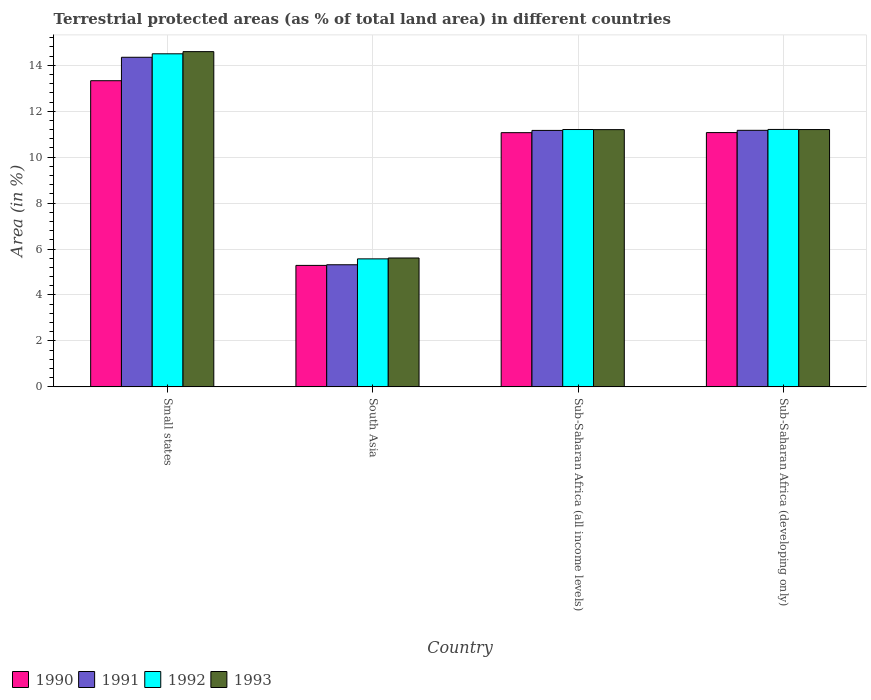Are the number of bars on each tick of the X-axis equal?
Keep it short and to the point. Yes. In how many cases, is the number of bars for a given country not equal to the number of legend labels?
Provide a short and direct response. 0. What is the percentage of terrestrial protected land in 1992 in South Asia?
Ensure brevity in your answer.  5.57. Across all countries, what is the maximum percentage of terrestrial protected land in 1991?
Offer a terse response. 14.35. Across all countries, what is the minimum percentage of terrestrial protected land in 1992?
Your response must be concise. 5.57. In which country was the percentage of terrestrial protected land in 1990 maximum?
Your answer should be very brief. Small states. What is the total percentage of terrestrial protected land in 1992 in the graph?
Your answer should be compact. 42.48. What is the difference between the percentage of terrestrial protected land in 1990 in South Asia and that in Sub-Saharan Africa (developing only)?
Provide a short and direct response. -5.78. What is the difference between the percentage of terrestrial protected land in 1992 in Sub-Saharan Africa (developing only) and the percentage of terrestrial protected land in 1993 in Small states?
Your response must be concise. -3.39. What is the average percentage of terrestrial protected land in 1993 per country?
Offer a very short reply. 10.65. What is the difference between the percentage of terrestrial protected land of/in 1991 and percentage of terrestrial protected land of/in 1990 in Sub-Saharan Africa (developing only)?
Offer a very short reply. 0.1. In how many countries, is the percentage of terrestrial protected land in 1993 greater than 4.8 %?
Make the answer very short. 4. What is the ratio of the percentage of terrestrial protected land in 1992 in Small states to that in Sub-Saharan Africa (all income levels)?
Your response must be concise. 1.29. Is the percentage of terrestrial protected land in 1991 in Small states less than that in Sub-Saharan Africa (developing only)?
Provide a succinct answer. No. What is the difference between the highest and the second highest percentage of terrestrial protected land in 1993?
Provide a succinct answer. -0. What is the difference between the highest and the lowest percentage of terrestrial protected land in 1992?
Make the answer very short. 8.93. In how many countries, is the percentage of terrestrial protected land in 1992 greater than the average percentage of terrestrial protected land in 1992 taken over all countries?
Your answer should be very brief. 3. Is the sum of the percentage of terrestrial protected land in 1991 in South Asia and Sub-Saharan Africa (all income levels) greater than the maximum percentage of terrestrial protected land in 1993 across all countries?
Give a very brief answer. Yes. What does the 4th bar from the right in South Asia represents?
Ensure brevity in your answer.  1990. How many bars are there?
Ensure brevity in your answer.  16. Does the graph contain any zero values?
Give a very brief answer. No. How many legend labels are there?
Give a very brief answer. 4. How are the legend labels stacked?
Make the answer very short. Horizontal. What is the title of the graph?
Your answer should be very brief. Terrestrial protected areas (as % of total land area) in different countries. What is the label or title of the Y-axis?
Provide a short and direct response. Area (in %). What is the Area (in %) of 1990 in Small states?
Offer a terse response. 13.33. What is the Area (in %) in 1991 in Small states?
Provide a succinct answer. 14.35. What is the Area (in %) in 1992 in Small states?
Provide a succinct answer. 14.5. What is the Area (in %) of 1993 in Small states?
Make the answer very short. 14.59. What is the Area (in %) of 1990 in South Asia?
Your answer should be very brief. 5.29. What is the Area (in %) of 1991 in South Asia?
Your answer should be compact. 5.32. What is the Area (in %) of 1992 in South Asia?
Provide a short and direct response. 5.57. What is the Area (in %) in 1993 in South Asia?
Provide a succinct answer. 5.61. What is the Area (in %) in 1990 in Sub-Saharan Africa (all income levels)?
Make the answer very short. 11.07. What is the Area (in %) of 1991 in Sub-Saharan Africa (all income levels)?
Offer a very short reply. 11.16. What is the Area (in %) in 1992 in Sub-Saharan Africa (all income levels)?
Give a very brief answer. 11.2. What is the Area (in %) in 1993 in Sub-Saharan Africa (all income levels)?
Provide a short and direct response. 11.2. What is the Area (in %) of 1990 in Sub-Saharan Africa (developing only)?
Keep it short and to the point. 11.07. What is the Area (in %) in 1991 in Sub-Saharan Africa (developing only)?
Your response must be concise. 11.17. What is the Area (in %) of 1992 in Sub-Saharan Africa (developing only)?
Your answer should be very brief. 11.21. What is the Area (in %) of 1993 in Sub-Saharan Africa (developing only)?
Your response must be concise. 11.2. Across all countries, what is the maximum Area (in %) of 1990?
Offer a very short reply. 13.33. Across all countries, what is the maximum Area (in %) in 1991?
Keep it short and to the point. 14.35. Across all countries, what is the maximum Area (in %) of 1992?
Ensure brevity in your answer.  14.5. Across all countries, what is the maximum Area (in %) in 1993?
Offer a very short reply. 14.59. Across all countries, what is the minimum Area (in %) in 1990?
Your response must be concise. 5.29. Across all countries, what is the minimum Area (in %) of 1991?
Ensure brevity in your answer.  5.32. Across all countries, what is the minimum Area (in %) of 1992?
Offer a very short reply. 5.57. Across all countries, what is the minimum Area (in %) in 1993?
Give a very brief answer. 5.61. What is the total Area (in %) of 1990 in the graph?
Offer a very short reply. 40.75. What is the total Area (in %) of 1991 in the graph?
Your answer should be very brief. 42. What is the total Area (in %) in 1992 in the graph?
Your answer should be very brief. 42.48. What is the total Area (in %) of 1993 in the graph?
Your answer should be very brief. 42.6. What is the difference between the Area (in %) of 1990 in Small states and that in South Asia?
Your answer should be very brief. 8.04. What is the difference between the Area (in %) in 1991 in Small states and that in South Asia?
Offer a terse response. 9.03. What is the difference between the Area (in %) in 1992 in Small states and that in South Asia?
Your answer should be very brief. 8.93. What is the difference between the Area (in %) in 1993 in Small states and that in South Asia?
Offer a very short reply. 8.98. What is the difference between the Area (in %) in 1990 in Small states and that in Sub-Saharan Africa (all income levels)?
Provide a succinct answer. 2.26. What is the difference between the Area (in %) in 1991 in Small states and that in Sub-Saharan Africa (all income levels)?
Your answer should be very brief. 3.18. What is the difference between the Area (in %) of 1992 in Small states and that in Sub-Saharan Africa (all income levels)?
Offer a terse response. 3.3. What is the difference between the Area (in %) of 1993 in Small states and that in Sub-Saharan Africa (all income levels)?
Offer a terse response. 3.4. What is the difference between the Area (in %) of 1990 in Small states and that in Sub-Saharan Africa (developing only)?
Make the answer very short. 2.26. What is the difference between the Area (in %) of 1991 in Small states and that in Sub-Saharan Africa (developing only)?
Your answer should be very brief. 3.18. What is the difference between the Area (in %) of 1992 in Small states and that in Sub-Saharan Africa (developing only)?
Your answer should be very brief. 3.29. What is the difference between the Area (in %) of 1993 in Small states and that in Sub-Saharan Africa (developing only)?
Provide a succinct answer. 3.39. What is the difference between the Area (in %) of 1990 in South Asia and that in Sub-Saharan Africa (all income levels)?
Your answer should be very brief. -5.78. What is the difference between the Area (in %) of 1991 in South Asia and that in Sub-Saharan Africa (all income levels)?
Your answer should be very brief. -5.85. What is the difference between the Area (in %) of 1992 in South Asia and that in Sub-Saharan Africa (all income levels)?
Provide a short and direct response. -5.63. What is the difference between the Area (in %) of 1993 in South Asia and that in Sub-Saharan Africa (all income levels)?
Offer a very short reply. -5.59. What is the difference between the Area (in %) of 1990 in South Asia and that in Sub-Saharan Africa (developing only)?
Keep it short and to the point. -5.78. What is the difference between the Area (in %) in 1991 in South Asia and that in Sub-Saharan Africa (developing only)?
Offer a very short reply. -5.85. What is the difference between the Area (in %) of 1992 in South Asia and that in Sub-Saharan Africa (developing only)?
Provide a succinct answer. -5.63. What is the difference between the Area (in %) in 1993 in South Asia and that in Sub-Saharan Africa (developing only)?
Offer a terse response. -5.59. What is the difference between the Area (in %) in 1990 in Sub-Saharan Africa (all income levels) and that in Sub-Saharan Africa (developing only)?
Your response must be concise. -0. What is the difference between the Area (in %) of 1991 in Sub-Saharan Africa (all income levels) and that in Sub-Saharan Africa (developing only)?
Your answer should be very brief. -0. What is the difference between the Area (in %) in 1992 in Sub-Saharan Africa (all income levels) and that in Sub-Saharan Africa (developing only)?
Ensure brevity in your answer.  -0. What is the difference between the Area (in %) of 1993 in Sub-Saharan Africa (all income levels) and that in Sub-Saharan Africa (developing only)?
Your answer should be very brief. -0. What is the difference between the Area (in %) in 1990 in Small states and the Area (in %) in 1991 in South Asia?
Provide a succinct answer. 8.01. What is the difference between the Area (in %) of 1990 in Small states and the Area (in %) of 1992 in South Asia?
Provide a succinct answer. 7.76. What is the difference between the Area (in %) in 1990 in Small states and the Area (in %) in 1993 in South Asia?
Give a very brief answer. 7.72. What is the difference between the Area (in %) of 1991 in Small states and the Area (in %) of 1992 in South Asia?
Provide a succinct answer. 8.78. What is the difference between the Area (in %) of 1991 in Small states and the Area (in %) of 1993 in South Asia?
Make the answer very short. 8.74. What is the difference between the Area (in %) of 1992 in Small states and the Area (in %) of 1993 in South Asia?
Your answer should be compact. 8.89. What is the difference between the Area (in %) of 1990 in Small states and the Area (in %) of 1991 in Sub-Saharan Africa (all income levels)?
Ensure brevity in your answer.  2.16. What is the difference between the Area (in %) of 1990 in Small states and the Area (in %) of 1992 in Sub-Saharan Africa (all income levels)?
Provide a short and direct response. 2.13. What is the difference between the Area (in %) in 1990 in Small states and the Area (in %) in 1993 in Sub-Saharan Africa (all income levels)?
Keep it short and to the point. 2.13. What is the difference between the Area (in %) in 1991 in Small states and the Area (in %) in 1992 in Sub-Saharan Africa (all income levels)?
Provide a short and direct response. 3.15. What is the difference between the Area (in %) in 1991 in Small states and the Area (in %) in 1993 in Sub-Saharan Africa (all income levels)?
Give a very brief answer. 3.15. What is the difference between the Area (in %) of 1992 in Small states and the Area (in %) of 1993 in Sub-Saharan Africa (all income levels)?
Offer a very short reply. 3.3. What is the difference between the Area (in %) in 1990 in Small states and the Area (in %) in 1991 in Sub-Saharan Africa (developing only)?
Ensure brevity in your answer.  2.16. What is the difference between the Area (in %) of 1990 in Small states and the Area (in %) of 1992 in Sub-Saharan Africa (developing only)?
Offer a very short reply. 2.12. What is the difference between the Area (in %) in 1990 in Small states and the Area (in %) in 1993 in Sub-Saharan Africa (developing only)?
Provide a succinct answer. 2.13. What is the difference between the Area (in %) in 1991 in Small states and the Area (in %) in 1992 in Sub-Saharan Africa (developing only)?
Provide a short and direct response. 3.14. What is the difference between the Area (in %) in 1991 in Small states and the Area (in %) in 1993 in Sub-Saharan Africa (developing only)?
Your answer should be compact. 3.15. What is the difference between the Area (in %) of 1992 in Small states and the Area (in %) of 1993 in Sub-Saharan Africa (developing only)?
Your answer should be compact. 3.3. What is the difference between the Area (in %) in 1990 in South Asia and the Area (in %) in 1991 in Sub-Saharan Africa (all income levels)?
Provide a short and direct response. -5.88. What is the difference between the Area (in %) of 1990 in South Asia and the Area (in %) of 1992 in Sub-Saharan Africa (all income levels)?
Make the answer very short. -5.91. What is the difference between the Area (in %) of 1990 in South Asia and the Area (in %) of 1993 in Sub-Saharan Africa (all income levels)?
Provide a succinct answer. -5.91. What is the difference between the Area (in %) in 1991 in South Asia and the Area (in %) in 1992 in Sub-Saharan Africa (all income levels)?
Offer a very short reply. -5.89. What is the difference between the Area (in %) in 1991 in South Asia and the Area (in %) in 1993 in Sub-Saharan Africa (all income levels)?
Provide a succinct answer. -5.88. What is the difference between the Area (in %) in 1992 in South Asia and the Area (in %) in 1993 in Sub-Saharan Africa (all income levels)?
Keep it short and to the point. -5.63. What is the difference between the Area (in %) in 1990 in South Asia and the Area (in %) in 1991 in Sub-Saharan Africa (developing only)?
Offer a very short reply. -5.88. What is the difference between the Area (in %) of 1990 in South Asia and the Area (in %) of 1992 in Sub-Saharan Africa (developing only)?
Keep it short and to the point. -5.92. What is the difference between the Area (in %) in 1990 in South Asia and the Area (in %) in 1993 in Sub-Saharan Africa (developing only)?
Your answer should be compact. -5.91. What is the difference between the Area (in %) of 1991 in South Asia and the Area (in %) of 1992 in Sub-Saharan Africa (developing only)?
Keep it short and to the point. -5.89. What is the difference between the Area (in %) in 1991 in South Asia and the Area (in %) in 1993 in Sub-Saharan Africa (developing only)?
Offer a terse response. -5.89. What is the difference between the Area (in %) of 1992 in South Asia and the Area (in %) of 1993 in Sub-Saharan Africa (developing only)?
Provide a short and direct response. -5.63. What is the difference between the Area (in %) of 1990 in Sub-Saharan Africa (all income levels) and the Area (in %) of 1991 in Sub-Saharan Africa (developing only)?
Your answer should be compact. -0.1. What is the difference between the Area (in %) of 1990 in Sub-Saharan Africa (all income levels) and the Area (in %) of 1992 in Sub-Saharan Africa (developing only)?
Make the answer very short. -0.14. What is the difference between the Area (in %) of 1990 in Sub-Saharan Africa (all income levels) and the Area (in %) of 1993 in Sub-Saharan Africa (developing only)?
Your answer should be very brief. -0.14. What is the difference between the Area (in %) in 1991 in Sub-Saharan Africa (all income levels) and the Area (in %) in 1992 in Sub-Saharan Africa (developing only)?
Provide a short and direct response. -0.04. What is the difference between the Area (in %) of 1991 in Sub-Saharan Africa (all income levels) and the Area (in %) of 1993 in Sub-Saharan Africa (developing only)?
Ensure brevity in your answer.  -0.04. What is the difference between the Area (in %) in 1992 in Sub-Saharan Africa (all income levels) and the Area (in %) in 1993 in Sub-Saharan Africa (developing only)?
Your answer should be compact. 0. What is the average Area (in %) of 1990 per country?
Provide a short and direct response. 10.19. What is the average Area (in %) in 1991 per country?
Provide a succinct answer. 10.5. What is the average Area (in %) of 1992 per country?
Provide a succinct answer. 10.62. What is the average Area (in %) in 1993 per country?
Your answer should be very brief. 10.65. What is the difference between the Area (in %) of 1990 and Area (in %) of 1991 in Small states?
Offer a terse response. -1.02. What is the difference between the Area (in %) in 1990 and Area (in %) in 1992 in Small states?
Give a very brief answer. -1.17. What is the difference between the Area (in %) of 1990 and Area (in %) of 1993 in Small states?
Your answer should be compact. -1.27. What is the difference between the Area (in %) in 1991 and Area (in %) in 1992 in Small states?
Make the answer very short. -0.15. What is the difference between the Area (in %) of 1991 and Area (in %) of 1993 in Small states?
Offer a very short reply. -0.25. What is the difference between the Area (in %) of 1992 and Area (in %) of 1993 in Small states?
Ensure brevity in your answer.  -0.09. What is the difference between the Area (in %) of 1990 and Area (in %) of 1991 in South Asia?
Provide a succinct answer. -0.03. What is the difference between the Area (in %) of 1990 and Area (in %) of 1992 in South Asia?
Ensure brevity in your answer.  -0.28. What is the difference between the Area (in %) in 1990 and Area (in %) in 1993 in South Asia?
Ensure brevity in your answer.  -0.32. What is the difference between the Area (in %) in 1991 and Area (in %) in 1992 in South Asia?
Keep it short and to the point. -0.26. What is the difference between the Area (in %) of 1991 and Area (in %) of 1993 in South Asia?
Provide a short and direct response. -0.29. What is the difference between the Area (in %) of 1992 and Area (in %) of 1993 in South Asia?
Make the answer very short. -0.04. What is the difference between the Area (in %) of 1990 and Area (in %) of 1991 in Sub-Saharan Africa (all income levels)?
Give a very brief answer. -0.1. What is the difference between the Area (in %) in 1990 and Area (in %) in 1992 in Sub-Saharan Africa (all income levels)?
Your answer should be very brief. -0.14. What is the difference between the Area (in %) in 1990 and Area (in %) in 1993 in Sub-Saharan Africa (all income levels)?
Give a very brief answer. -0.13. What is the difference between the Area (in %) in 1991 and Area (in %) in 1992 in Sub-Saharan Africa (all income levels)?
Ensure brevity in your answer.  -0.04. What is the difference between the Area (in %) in 1991 and Area (in %) in 1993 in Sub-Saharan Africa (all income levels)?
Provide a short and direct response. -0.03. What is the difference between the Area (in %) of 1992 and Area (in %) of 1993 in Sub-Saharan Africa (all income levels)?
Keep it short and to the point. 0. What is the difference between the Area (in %) in 1990 and Area (in %) in 1991 in Sub-Saharan Africa (developing only)?
Offer a terse response. -0.1. What is the difference between the Area (in %) of 1990 and Area (in %) of 1992 in Sub-Saharan Africa (developing only)?
Offer a terse response. -0.14. What is the difference between the Area (in %) of 1990 and Area (in %) of 1993 in Sub-Saharan Africa (developing only)?
Keep it short and to the point. -0.13. What is the difference between the Area (in %) of 1991 and Area (in %) of 1992 in Sub-Saharan Africa (developing only)?
Keep it short and to the point. -0.04. What is the difference between the Area (in %) of 1991 and Area (in %) of 1993 in Sub-Saharan Africa (developing only)?
Give a very brief answer. -0.03. What is the difference between the Area (in %) in 1992 and Area (in %) in 1993 in Sub-Saharan Africa (developing only)?
Your answer should be very brief. 0. What is the ratio of the Area (in %) of 1990 in Small states to that in South Asia?
Your answer should be compact. 2.52. What is the ratio of the Area (in %) of 1991 in Small states to that in South Asia?
Your response must be concise. 2.7. What is the ratio of the Area (in %) in 1992 in Small states to that in South Asia?
Make the answer very short. 2.6. What is the ratio of the Area (in %) in 1993 in Small states to that in South Asia?
Provide a short and direct response. 2.6. What is the ratio of the Area (in %) in 1990 in Small states to that in Sub-Saharan Africa (all income levels)?
Offer a very short reply. 1.2. What is the ratio of the Area (in %) in 1991 in Small states to that in Sub-Saharan Africa (all income levels)?
Keep it short and to the point. 1.29. What is the ratio of the Area (in %) in 1992 in Small states to that in Sub-Saharan Africa (all income levels)?
Keep it short and to the point. 1.29. What is the ratio of the Area (in %) in 1993 in Small states to that in Sub-Saharan Africa (all income levels)?
Make the answer very short. 1.3. What is the ratio of the Area (in %) in 1990 in Small states to that in Sub-Saharan Africa (developing only)?
Your answer should be very brief. 1.2. What is the ratio of the Area (in %) of 1991 in Small states to that in Sub-Saharan Africa (developing only)?
Offer a very short reply. 1.28. What is the ratio of the Area (in %) in 1992 in Small states to that in Sub-Saharan Africa (developing only)?
Your response must be concise. 1.29. What is the ratio of the Area (in %) in 1993 in Small states to that in Sub-Saharan Africa (developing only)?
Keep it short and to the point. 1.3. What is the ratio of the Area (in %) of 1990 in South Asia to that in Sub-Saharan Africa (all income levels)?
Make the answer very short. 0.48. What is the ratio of the Area (in %) in 1991 in South Asia to that in Sub-Saharan Africa (all income levels)?
Offer a terse response. 0.48. What is the ratio of the Area (in %) in 1992 in South Asia to that in Sub-Saharan Africa (all income levels)?
Give a very brief answer. 0.5. What is the ratio of the Area (in %) in 1993 in South Asia to that in Sub-Saharan Africa (all income levels)?
Your answer should be compact. 0.5. What is the ratio of the Area (in %) in 1990 in South Asia to that in Sub-Saharan Africa (developing only)?
Your answer should be compact. 0.48. What is the ratio of the Area (in %) in 1991 in South Asia to that in Sub-Saharan Africa (developing only)?
Give a very brief answer. 0.48. What is the ratio of the Area (in %) of 1992 in South Asia to that in Sub-Saharan Africa (developing only)?
Keep it short and to the point. 0.5. What is the ratio of the Area (in %) of 1993 in South Asia to that in Sub-Saharan Africa (developing only)?
Your answer should be compact. 0.5. What is the ratio of the Area (in %) in 1990 in Sub-Saharan Africa (all income levels) to that in Sub-Saharan Africa (developing only)?
Keep it short and to the point. 1. What is the ratio of the Area (in %) in 1991 in Sub-Saharan Africa (all income levels) to that in Sub-Saharan Africa (developing only)?
Your answer should be very brief. 1. What is the ratio of the Area (in %) of 1992 in Sub-Saharan Africa (all income levels) to that in Sub-Saharan Africa (developing only)?
Make the answer very short. 1. What is the ratio of the Area (in %) in 1993 in Sub-Saharan Africa (all income levels) to that in Sub-Saharan Africa (developing only)?
Your response must be concise. 1. What is the difference between the highest and the second highest Area (in %) in 1990?
Provide a short and direct response. 2.26. What is the difference between the highest and the second highest Area (in %) in 1991?
Offer a terse response. 3.18. What is the difference between the highest and the second highest Area (in %) of 1992?
Give a very brief answer. 3.29. What is the difference between the highest and the second highest Area (in %) in 1993?
Your answer should be compact. 3.39. What is the difference between the highest and the lowest Area (in %) of 1990?
Keep it short and to the point. 8.04. What is the difference between the highest and the lowest Area (in %) of 1991?
Give a very brief answer. 9.03. What is the difference between the highest and the lowest Area (in %) in 1992?
Provide a short and direct response. 8.93. What is the difference between the highest and the lowest Area (in %) in 1993?
Offer a terse response. 8.98. 